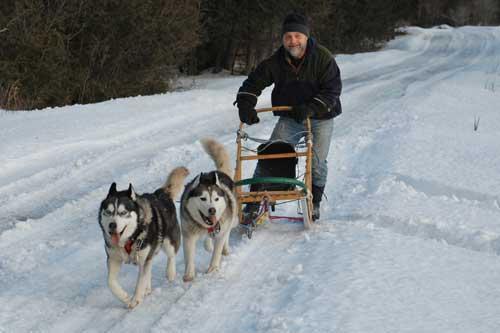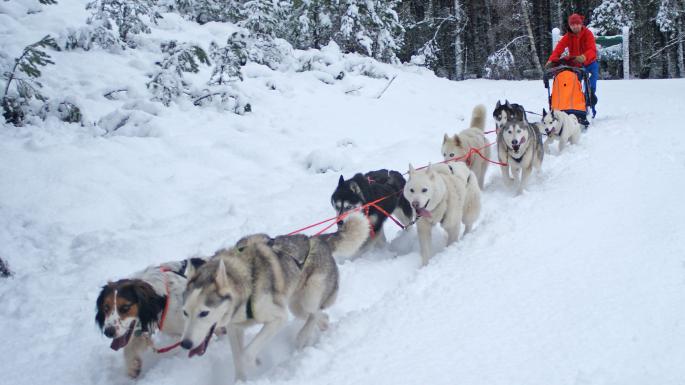The first image is the image on the left, the second image is the image on the right. For the images displayed, is the sentence "In at least one image there are no more than four dogs dragging a single man with a black hat on the back of a sled." factually correct? Answer yes or no. Yes. The first image is the image on the left, the second image is the image on the right. Examine the images to the left and right. Is the description "The right image shows a dog team moving rightward across the snow past a type of housing shelter on the right." accurate? Answer yes or no. No. 